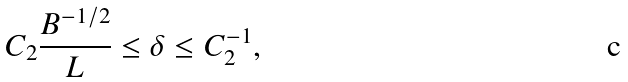Convert formula to latex. <formula><loc_0><loc_0><loc_500><loc_500>C _ { 2 } \frac { B ^ { - 1 / 2 } } { L } \leq \delta \leq C _ { 2 } ^ { - 1 } ,</formula> 